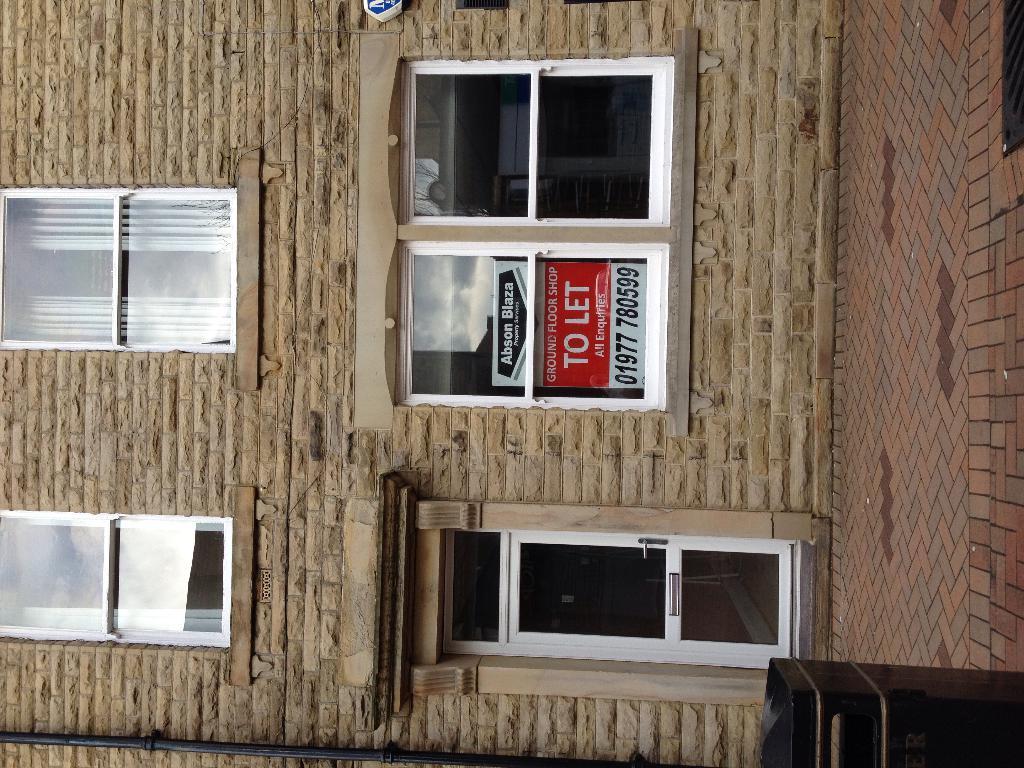How would you summarize this image in a sentence or two? This is the front view of a building where we can see glass windows, poster and door. On the right side of the image, we can see a pavement. There is a dustbin in the right bottom of the image. 